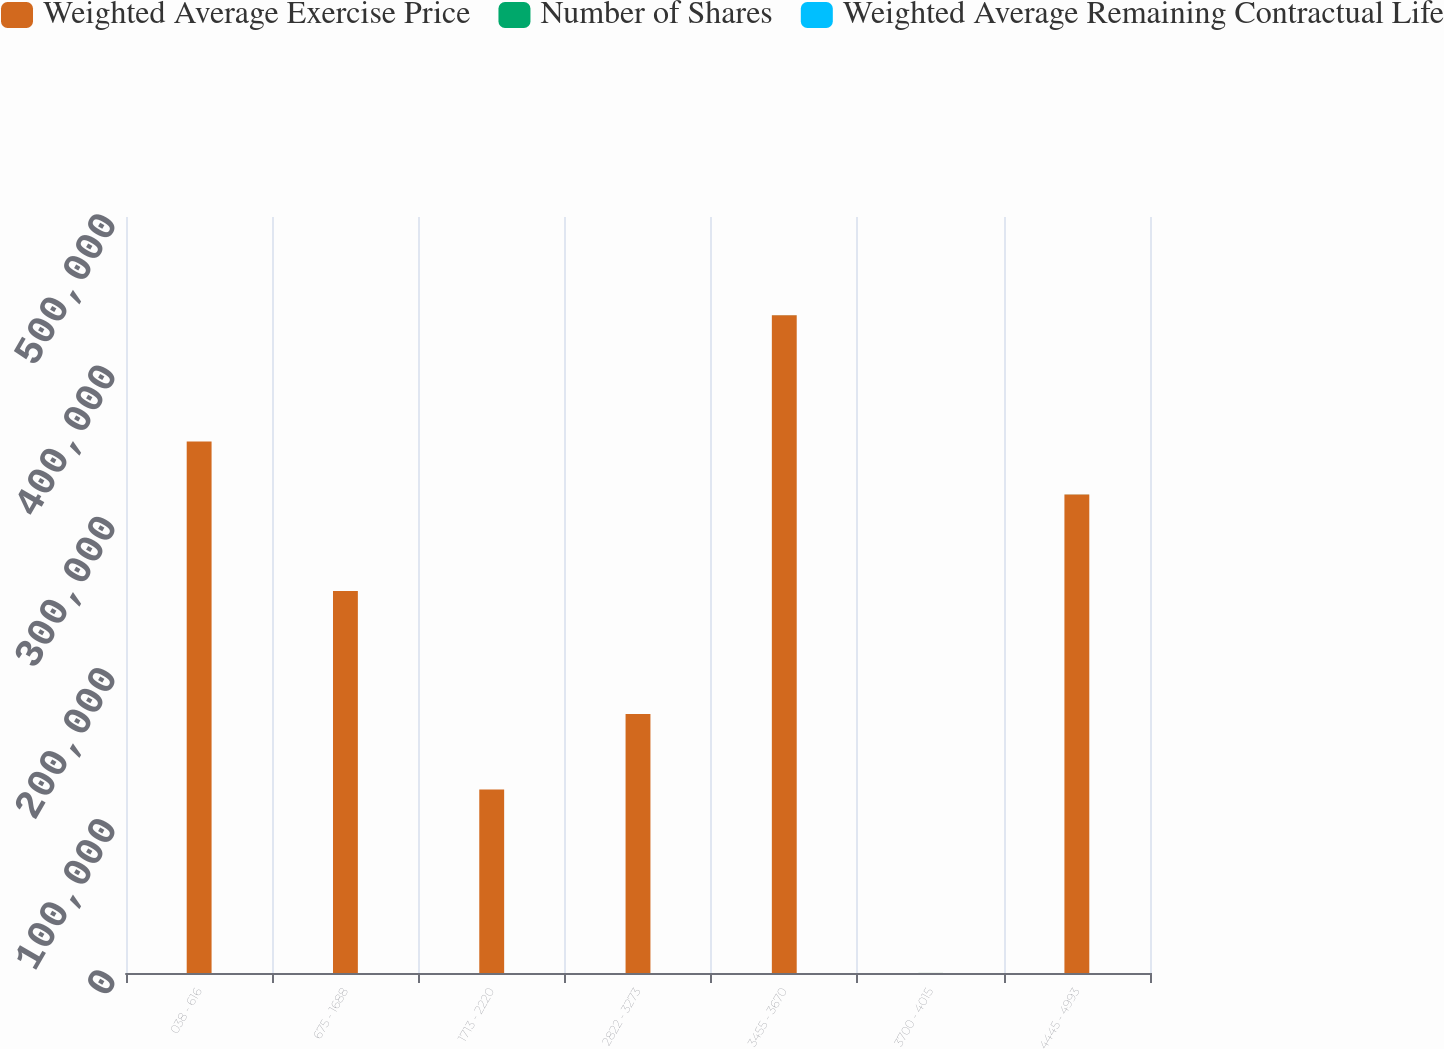Convert chart to OTSL. <chart><loc_0><loc_0><loc_500><loc_500><stacked_bar_chart><ecel><fcel>038 - 616<fcel>675 - 1688<fcel>1713 - 2220<fcel>2822 - 3273<fcel>3455 - 3670<fcel>3700 - 4015<fcel>4445 - 4993<nl><fcel>Weighted Average Exercise Price<fcel>351499<fcel>252711<fcel>121445<fcel>171281<fcel>434945<fcel>23.75<fcel>316500<nl><fcel>Number of Shares<fcel>6.1<fcel>10.88<fcel>18.52<fcel>28.98<fcel>36.67<fcel>37.02<fcel>47.06<nl><fcel>Weighted Average Remaining Contractual Life<fcel>7.7<fcel>5.9<fcel>6.2<fcel>8.7<fcel>9.7<fcel>9<fcel>9.2<nl></chart> 